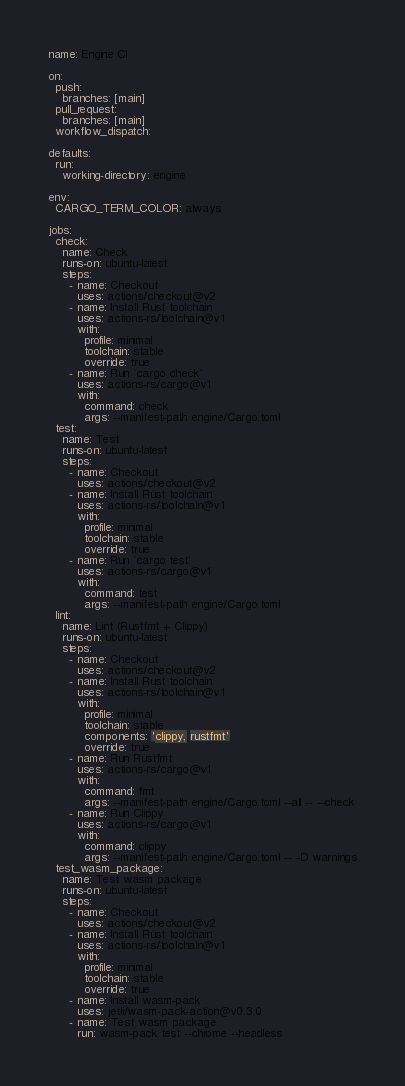<code> <loc_0><loc_0><loc_500><loc_500><_YAML_>name: Engine CI

on:
  push:
    branches: [main]
  pull_request:
    branches: [main]
  workflow_dispatch:

defaults:
  run:
    working-directory: engine

env:
  CARGO_TERM_COLOR: always

jobs:
  check:
    name: Check
    runs-on: ubuntu-latest
    steps:
      - name: Checkout
        uses: actions/checkout@v2
      - name: Install Rust toolchain
        uses: actions-rs/toolchain@v1
        with:
          profile: minimal
          toolchain: stable
          override: true
      - name: Run `cargo check`
        uses: actions-rs/cargo@v1
        with:
          command: check
          args: --manifest-path engine/Cargo.toml
  test:
    name: Test
    runs-on: ubuntu-latest
    steps:
      - name: Checkout
        uses: actions/checkout@v2
      - name: Install Rust toolchain
        uses: actions-rs/toolchain@v1
        with:
          profile: minimal
          toolchain: stable
          override: true
      - name: Run `cargo test`
        uses: actions-rs/cargo@v1
        with:
          command: test
          args: --manifest-path engine/Cargo.toml
  lint:
    name: Lint (Rustfmt + Clippy)
    runs-on: ubuntu-latest
    steps:
      - name: Checkout
        uses: actions/checkout@v2
      - name: Install Rust toolchain
        uses: actions-rs/toolchain@v1
        with:
          profile: minimal
          toolchain: stable
          components: 'clippy, rustfmt'
          override: true
      - name: Run Rustfmt
        uses: actions-rs/cargo@v1
        with:
          command: fmt
          args: --manifest-path engine/Cargo.toml --all -- --check
      - name: Run Clippy
        uses: actions-rs/cargo@v1
        with:
          command: clippy
          args: --manifest-path engine/Cargo.toml -- -D warnings
  test_wasm_package:
    name: Test wasm package
    runs-on: ubuntu-latest
    steps:
      - name: Checkout
        uses: actions/checkout@v2
      - name: Install Rust toolchain
        uses: actions-rs/toolchain@v1
        with:
          profile: minimal
          toolchain: stable
          override: true
      - name: Install wasm-pack
        uses: jetli/wasm-pack-action@v0.3.0
      - name: Test wasm package
        run: wasm-pack test --chrome --headless
</code> 